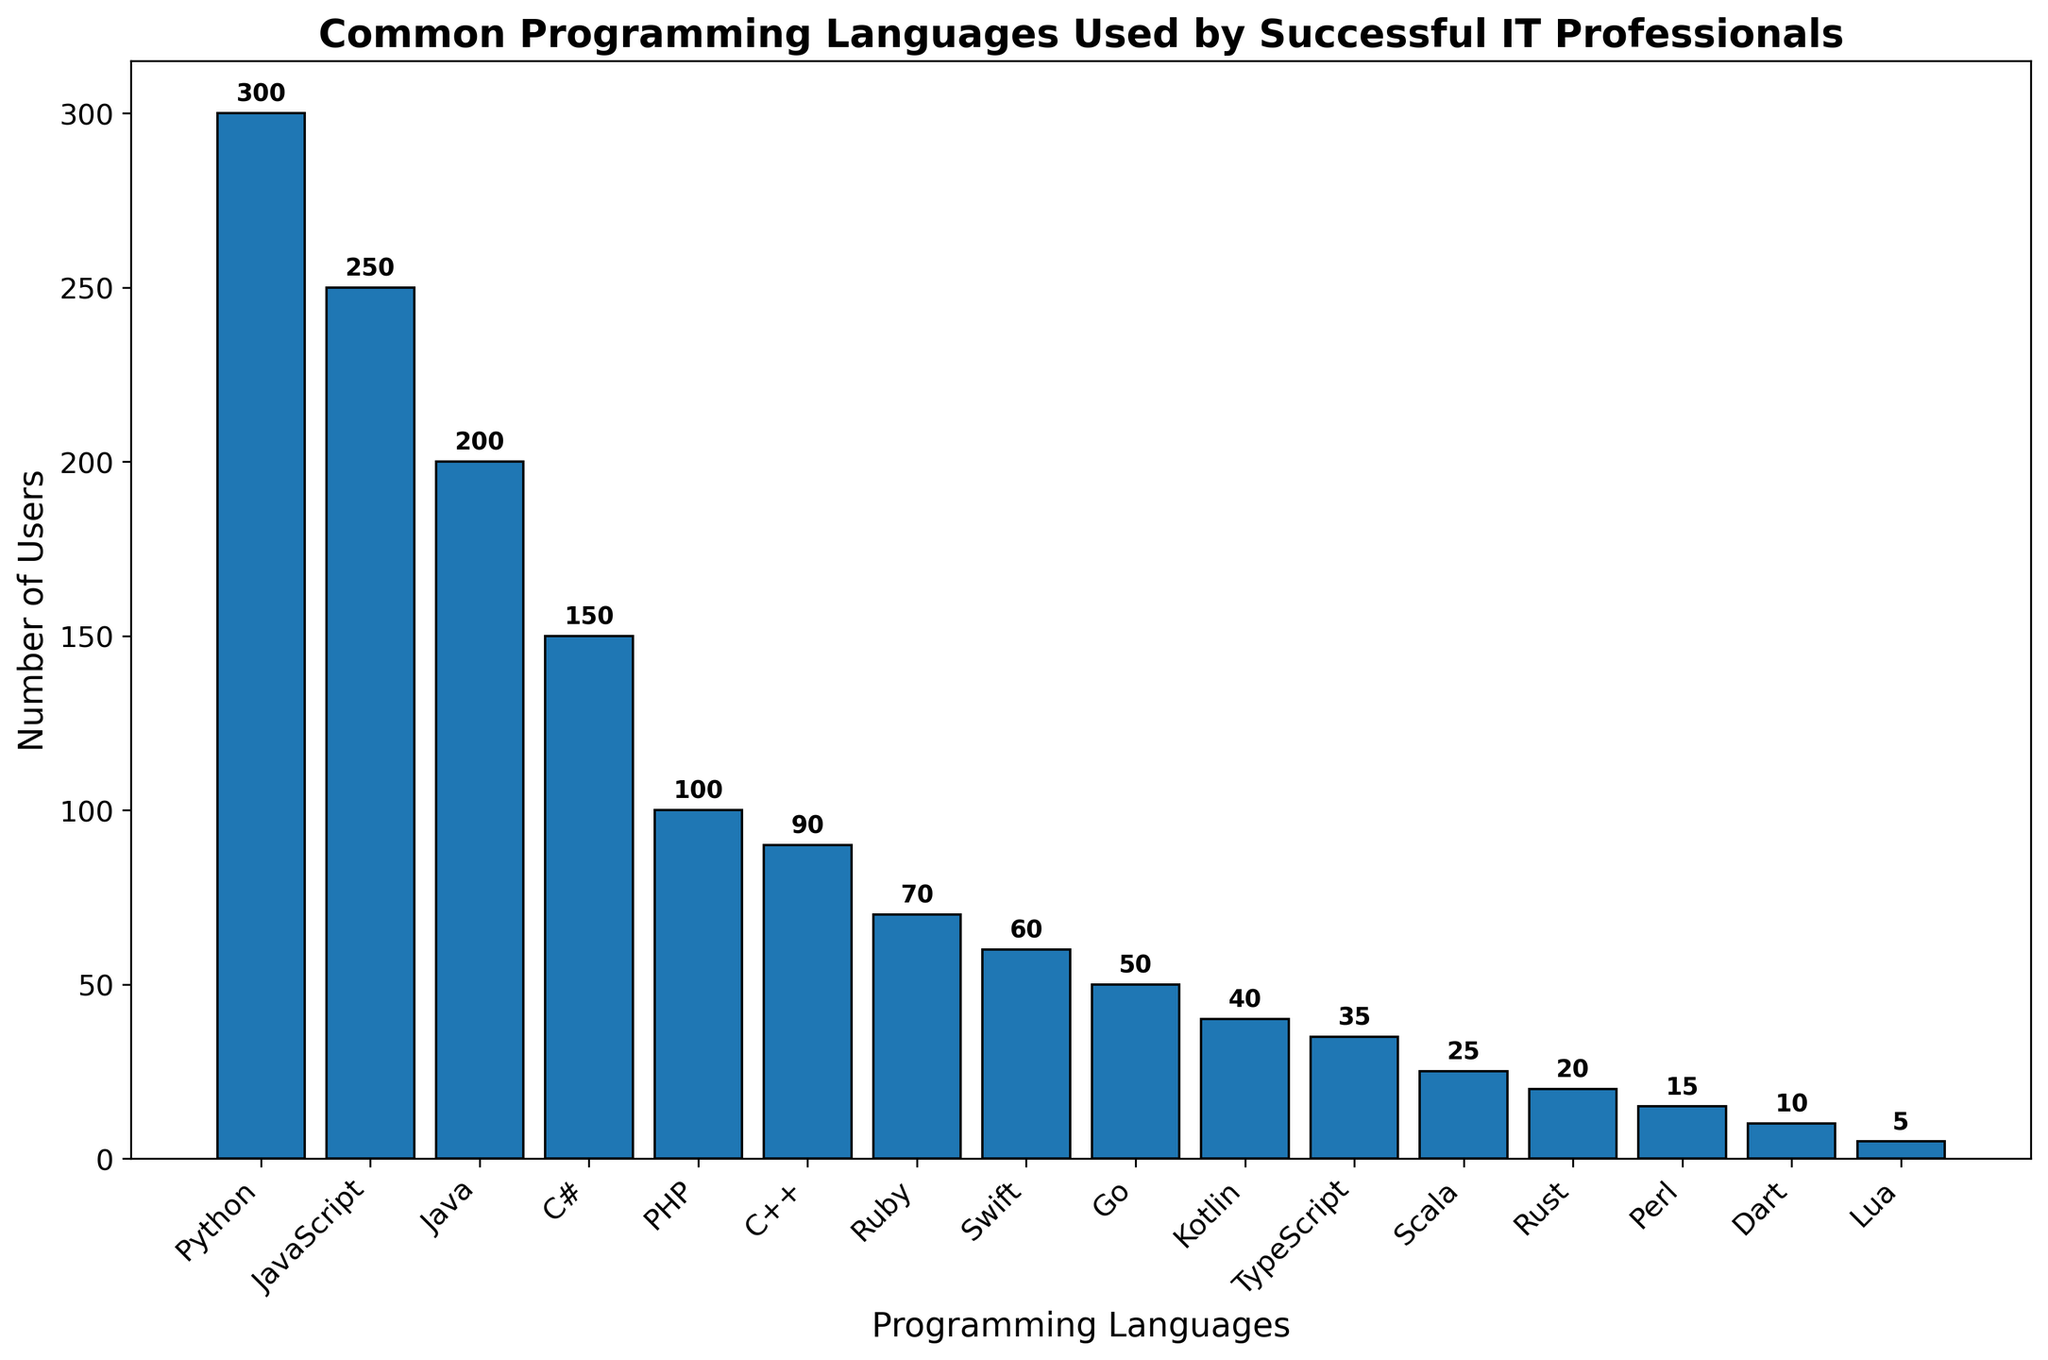What's the most commonly used programming language among successful IT professionals? Look for the bar with the greatest height and refer to its label. The tallest bar corresponds to Python.
Answer: Python Which programming language has 100 users? Identify the bar that reaches up to 100 on the y-axis and refer to the label on the x-axis. The bar for PHP reaches 100 users.
Answer: PHP How many more users does JavaScript have compared to C++? Determine the height values for the JavaScript and C++ bars. JavaScript has 250 users and C++ has 90 users, so subtract the smaller from the larger (250 - 90).
Answer: 160 What is the total number of users for JavaScript, Java, and C# combined? Look at the heights of the bars for JavaScript (250), Java (200), and C# (150). Sum these values (250 + 200 + 150).
Answer: 600 Which language has the smallest number of users, and how many? Find the shortest bar, which corresponds to Lua, and note the value on the y-axis.
Answer: Lua, 5 How does the number of users of Kotlin compare to that of Swift? Compare the heights of the bars for Kotlin and Swift. Kotlin has 40 users and Swift has 60 users. Kotlin has fewer users than Swift.
Answer: Kotlin has fewer users than Swift What is the difference in the number of users between the top three languages combined and the bottom three languages combined? Identify the top three languages (Python: 300, JavaScript: 250, Java: 200) and the bottom three languages (Perl: 15, Dart: 10, Lua: 5). Sum the users for each group (300 + 250 + 200 = 750) and (15 + 10 + 5 = 30). Subtract the smaller sum from the larger sum (750 - 30).
Answer: 720 What is the average number of users for Ruby, Go, and TypeScript? Look at the heights of the bars for Ruby (70), Go (50), and TypeScript (35). Sum these values (70 + 50 + 35 = 155) and divide by the number of languages (3).
Answer: 51.67 Which language has slightly fewer users than C++ but more than Dart? Compare the number of users for each language between C++ (90) and Dart (10). The language with slightly fewer users than C++ is Ruby with 70 users.
Answer: Ruby How many programming languages have fewer than 50 users? Identify all bars with heights less than 50. These languages are Kotlin (40), TypeScript (35), Scala (25), Rust (20), Perl (15), Dart (10), and Lua (5). Count them.
Answer: 7 